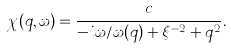<formula> <loc_0><loc_0><loc_500><loc_500>\chi ( { q } , \omega ) = \frac { c } { - i \omega / \omega ( { q } ) + \xi ^ { - 2 } + q ^ { 2 } } .</formula> 